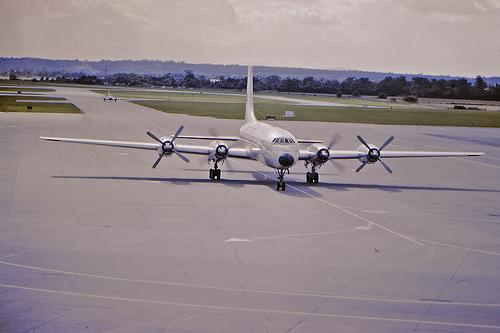Explain what the primary focus of the image is and mention the environment. The main focus is two airplanes on a runway, surrounded by grass, trees, and a cloudy sky. Mention the notable characteristics of the main subject and the surrounding environment. Airplanes with white bodies, propellers on wings, and wheels on a grey runway, surrounded by green trees and cloudy sky. In a simple sentence, describe what the image is showcasing. Two planes on a runway, one behind the other, with propellers on wings under a cloudy sky. Outline the primary features and setting of the image. Two propeller planes on a grey, airport runway with green trees in the background and a cloudy sky overhead. In one sentence, narrate the action occurring in the image. Two airplanes, one behind the other, are positioned on the runway with propellers on their wings. Summarize the content of the image and its surroundings in a simple sentence. Two propeller planes are on an airport runway with trees and cloudy sky in the background. Describe the overall scene in the image, including the main subject and its surroundings. Airplanes with propellers on their wings are moving on the airport runway with trees and a cloudy sky in the background. Identify the primary objects in the image and provide a brief description. Two airplanes on the runway, one in front of the other, with white bodies and four propellers on their wings. Write a descriptive sentence about the elements in the foreground of the image. A white passenger jet with propellers on its wings is on the runway followed by another plane. Provide a concise description of the scene in the image. Two airplanes on the airport runway, one behind the other, with propellers on their wings and a cloudy sky backdrop. 